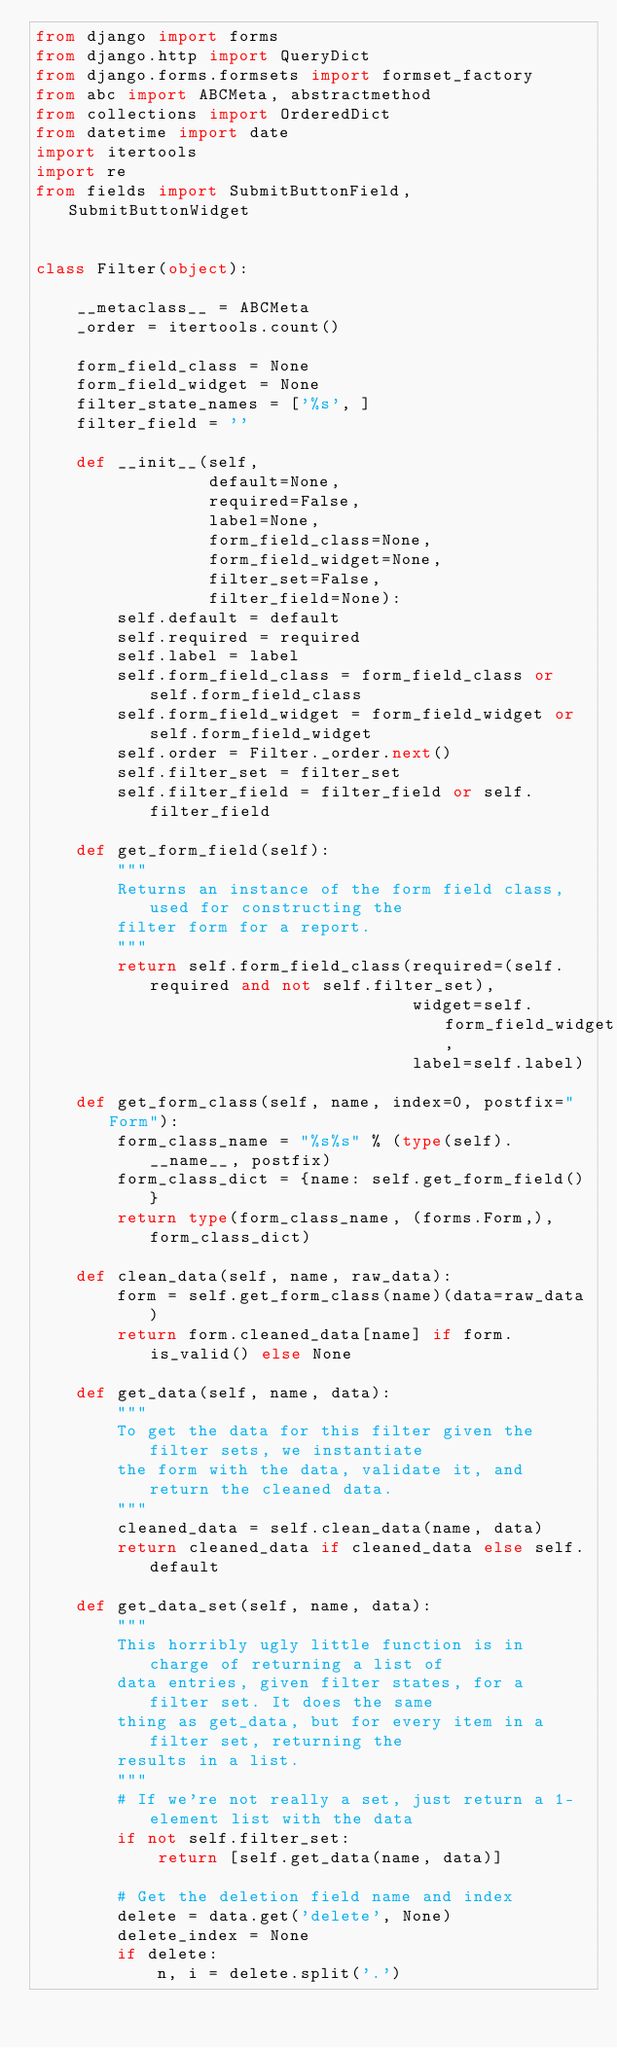Convert code to text. <code><loc_0><loc_0><loc_500><loc_500><_Python_>from django import forms
from django.http import QueryDict
from django.forms.formsets import formset_factory
from abc import ABCMeta, abstractmethod
from collections import OrderedDict
from datetime import date
import itertools
import re
from fields import SubmitButtonField, SubmitButtonWidget


class Filter(object):

    __metaclass__ = ABCMeta
    _order = itertools.count()

    form_field_class = None
    form_field_widget = None
    filter_state_names = ['%s', ]
    filter_field = ''

    def __init__(self,
                 default=None,
                 required=False,
                 label=None,
                 form_field_class=None,
                 form_field_widget=None,
                 filter_set=False,
                 filter_field=None):
        self.default = default
        self.required = required
        self.label = label
        self.form_field_class = form_field_class or self.form_field_class
        self.form_field_widget = form_field_widget or self.form_field_widget
        self.order = Filter._order.next()
        self.filter_set = filter_set
        self.filter_field = filter_field or self.filter_field

    def get_form_field(self):
        """
        Returns an instance of the form field class, used for constructing the
        filter form for a report.
        """
        return self.form_field_class(required=(self.required and not self.filter_set),
                                     widget=self.form_field_widget,
                                     label=self.label)

    def get_form_class(self, name, index=0, postfix="Form"):
        form_class_name = "%s%s" % (type(self).__name__, postfix)
        form_class_dict = {name: self.get_form_field()}
        return type(form_class_name, (forms.Form,), form_class_dict)

    def clean_data(self, name, raw_data):
        form = self.get_form_class(name)(data=raw_data)
        return form.cleaned_data[name] if form.is_valid() else None

    def get_data(self, name, data):
        """
        To get the data for this filter given the filter sets, we instantiate
        the form with the data, validate it, and return the cleaned data.
        """
        cleaned_data = self.clean_data(name, data)
        return cleaned_data if cleaned_data else self.default

    def get_data_set(self, name, data):
        """
        This horribly ugly little function is in charge of returning a list of
        data entries, given filter states, for a filter set. It does the same
        thing as get_data, but for every item in a filter set, returning the
        results in a list.
        """
        # If we're not really a set, just return a 1-element list with the data
        if not self.filter_set:
            return [self.get_data(name, data)]

        # Get the deletion field name and index
        delete = data.get('delete', None)
        delete_index = None
        if delete:
            n, i = delete.split('.')</code> 